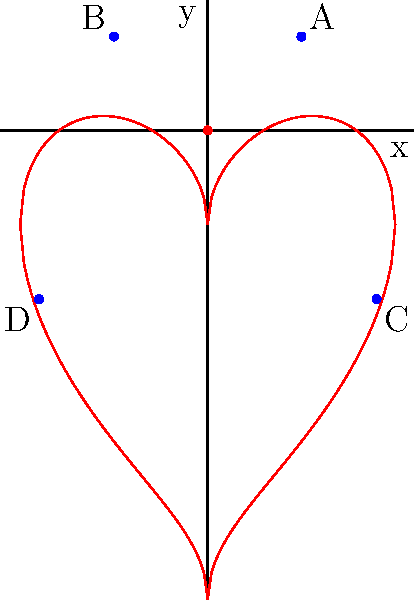In the coordinate plane above, a heart shape is drawn in red. Four points A, B, C, and D are marked in blue. Which of these points, when connected, would form a rectangle that encompasses the heart shape? Explain your reasoning and provide the coordinates of the chosen points. To solve this problem, let's follow these steps:

1) First, we need to identify the coordinates of the given points:
   A: $(0.5, 0.5)$
   B: $(-0.5, 0.5)$
   C: $(0.9, -0.9)$
   D: $(-0.9, -0.9)$

2) To encompass the heart shape, we need a rectangle that:
   - Is wide enough to include the leftmost and rightmost points of the heart
   - Is tall enough to include the highest and lowest points of the heart

3) Examining the heart shape, we can see that:
   - It extends from about -1 to 1 on the x-axis
   - It extends from about -1.5 to 1 on the y-axis

4) Looking at our given points:
   - Points C and D have x-coordinates of 0.9 and -0.9, which are close to the width of the heart
   - Points A and B have y-coordinates of 0.5, which is not high enough to encompass the top of the heart
   - Points C and D have y-coordinates of -0.9, which is not low enough to encompass the bottom of the heart

5) Therefore, the rectangle formed by these points would not fully encompass the heart shape. We would need points with coordinates closer to $(\pm 1, 1)$ for the top corners and $(\pm 1, -1.5)$ for the bottom corners to fully encompass the heart.

6) However, among the given points, the rectangle formed by connecting A, B, C, and D would come closest to encompassing the heart, even though it doesn't fully contain it.
Answer: Points A$(0.5, 0.5)$, B$(-0.5, 0.5)$, C$(0.9, -0.9)$, and D$(-0.9, -0.9)$ form the closest rectangle, but don't fully encompass the heart. 